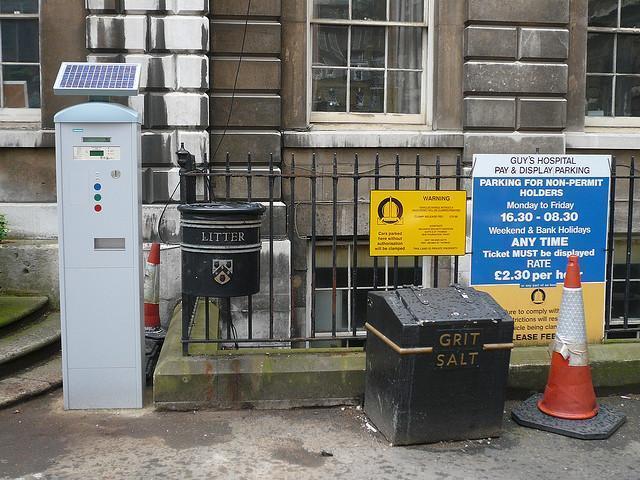How many parking meters are in the picture?
Give a very brief answer. 1. How many people are wearing sunglasses?
Give a very brief answer. 0. 